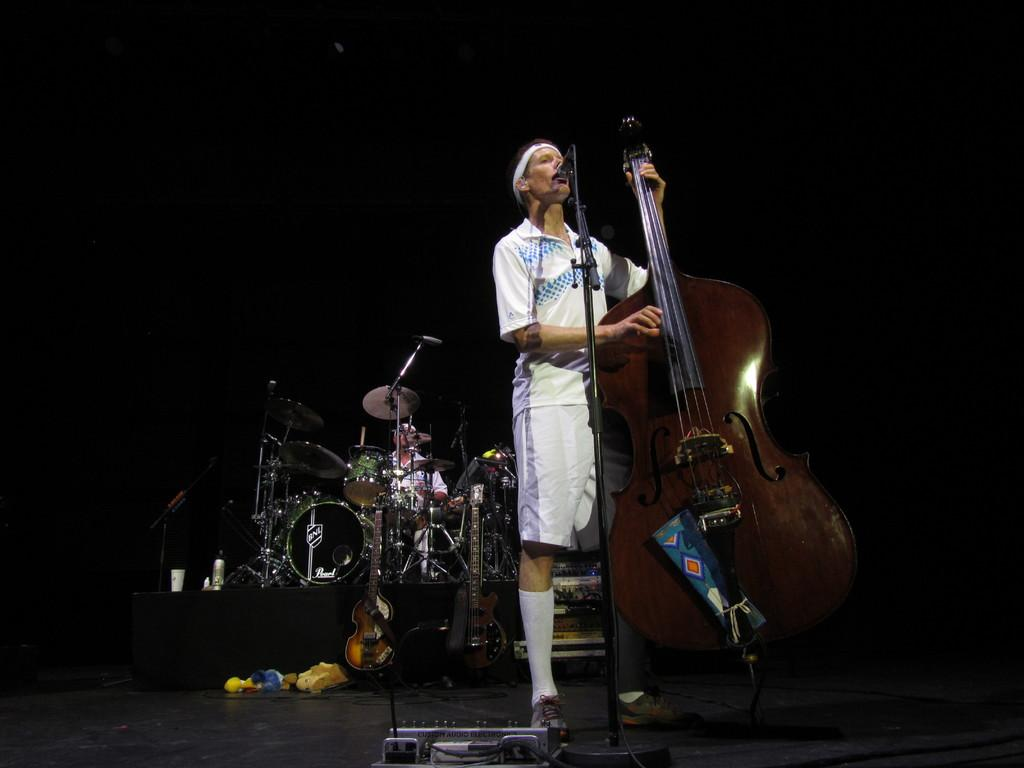How many people are in the image? There are two people in the image. What is the standing man holding in the image? The standing man is holding a guitar. What is the standing man doing with the microphone? The standing man is singing into the microphone. What is the sitting man doing in the image? The sitting man is playing musical drums. What action is the person taking with the action figure in the image? There is no action figure present in the image. The image features two people, one standing and holding a guitar while singing into a microphone, and the other sitting and playing musical drums. 